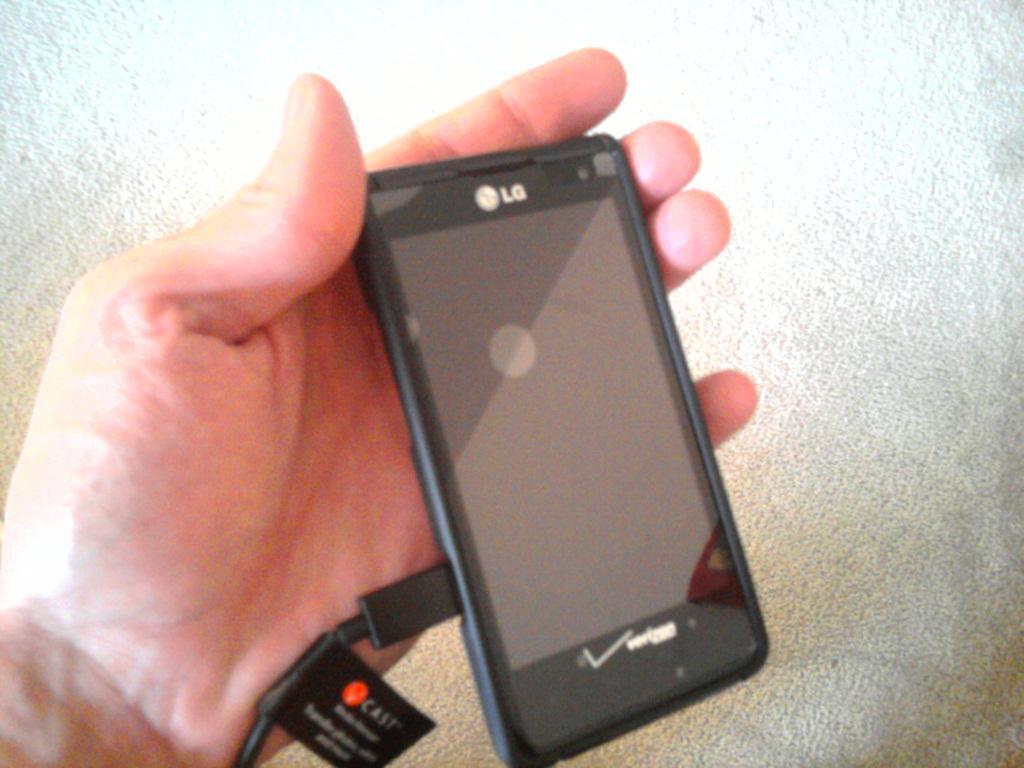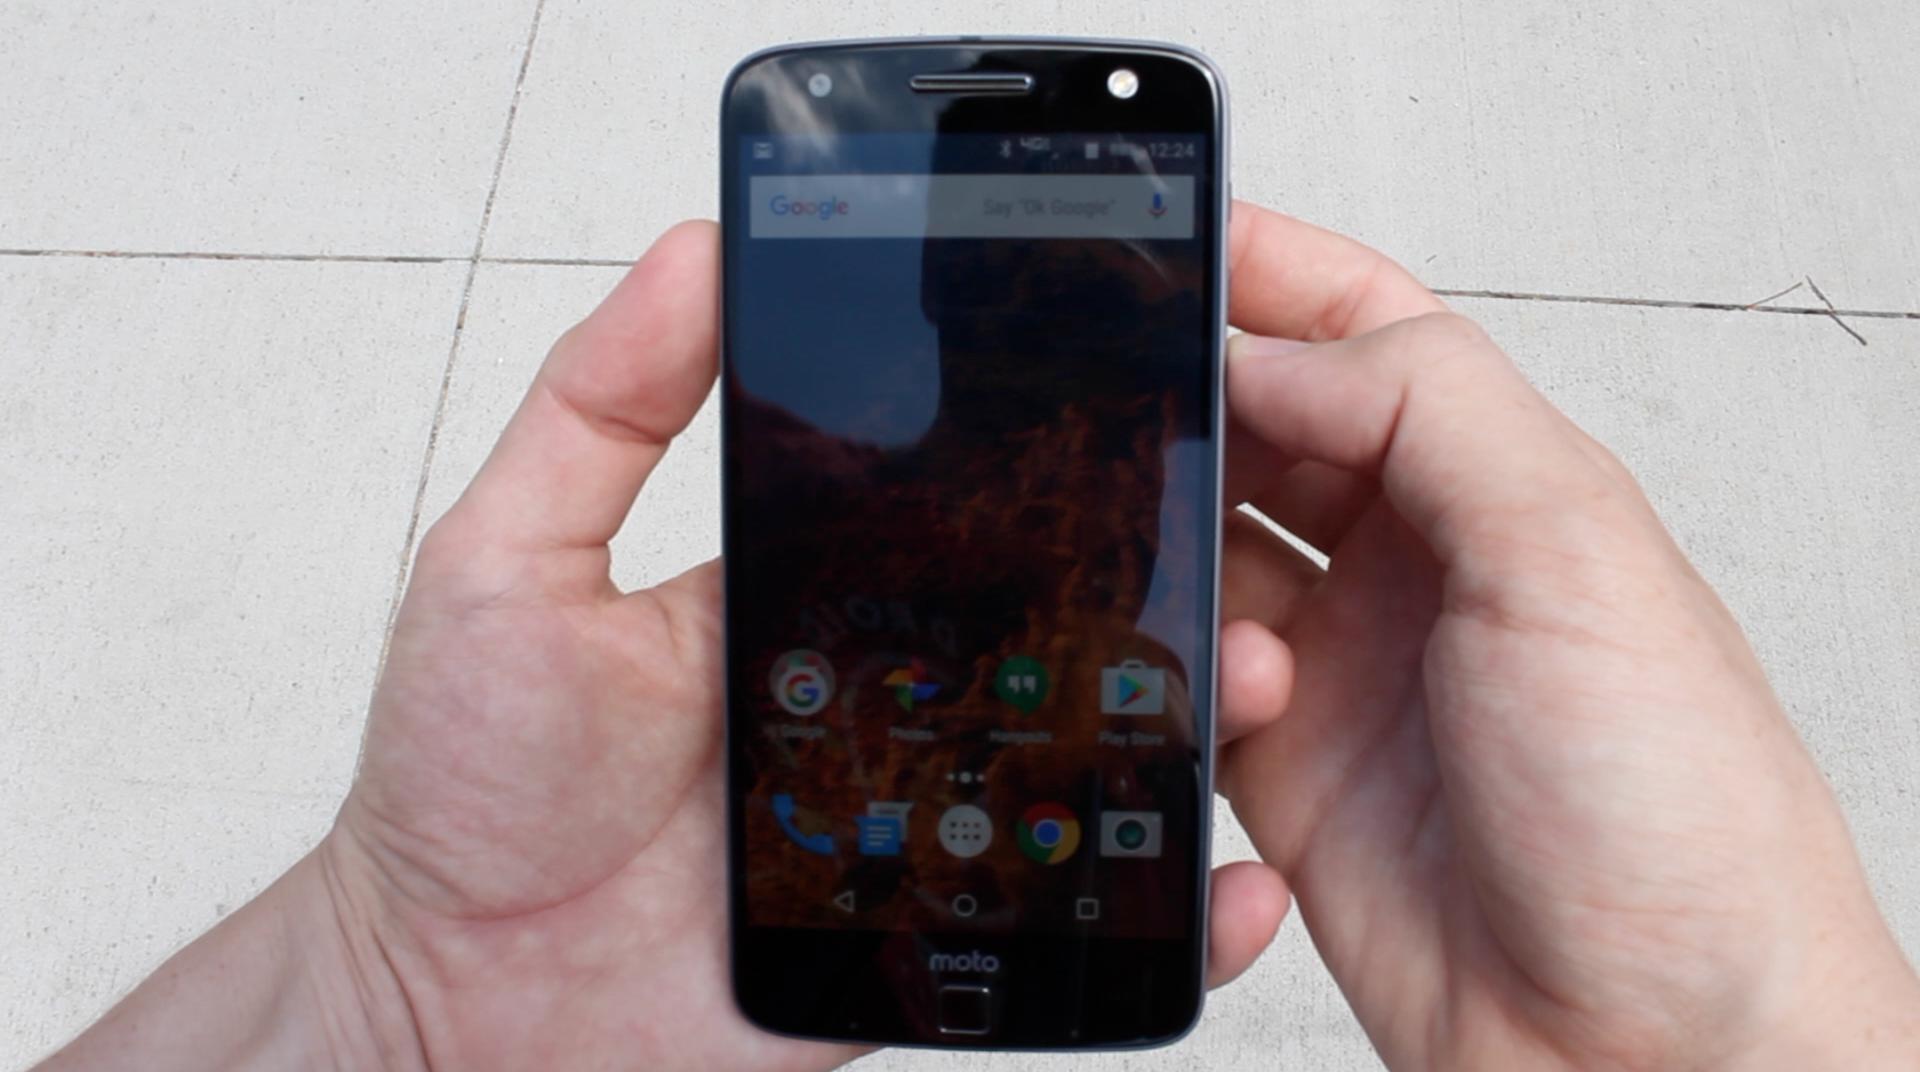The first image is the image on the left, the second image is the image on the right. Examine the images to the left and right. Is the description "Only one hand is visible." accurate? Answer yes or no. No. 